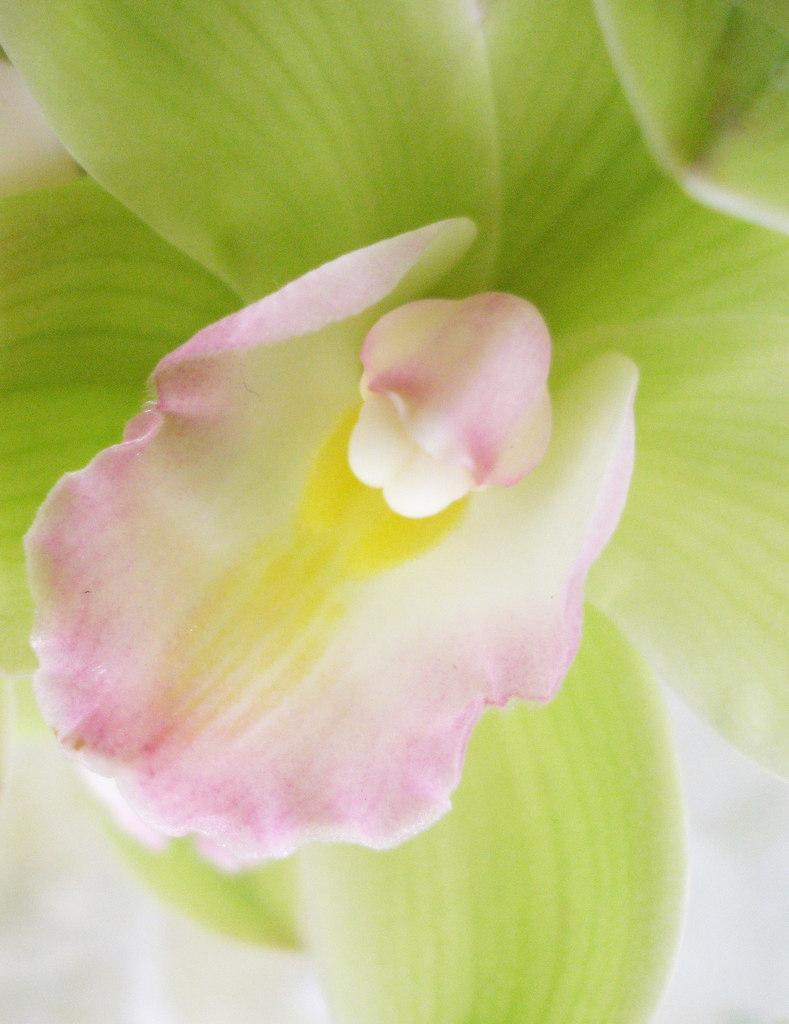In one or two sentences, can you explain what this image depicts? In this image I can see the flower which is in pink, white, yellow and green color. And there is a white background. 